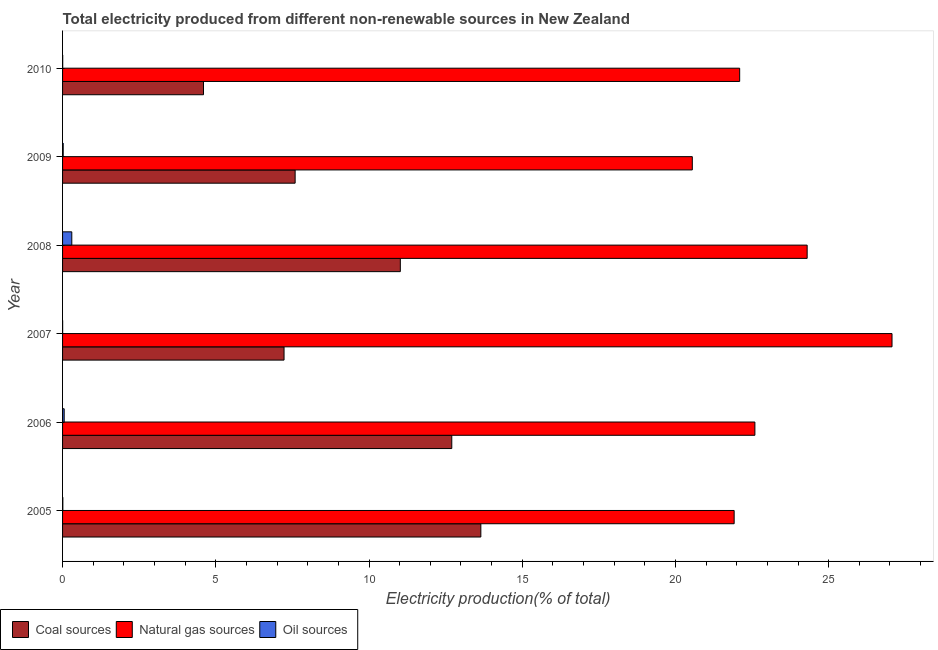How many different coloured bars are there?
Your answer should be very brief. 3. Are the number of bars per tick equal to the number of legend labels?
Provide a succinct answer. Yes. How many bars are there on the 1st tick from the bottom?
Provide a succinct answer. 3. What is the label of the 3rd group of bars from the top?
Offer a terse response. 2008. In how many cases, is the number of bars for a given year not equal to the number of legend labels?
Provide a short and direct response. 0. What is the percentage of electricity produced by natural gas in 2010?
Provide a succinct answer. 22.1. Across all years, what is the maximum percentage of electricity produced by natural gas?
Give a very brief answer. 27.07. Across all years, what is the minimum percentage of electricity produced by natural gas?
Offer a terse response. 20.55. What is the total percentage of electricity produced by oil sources in the graph?
Your answer should be compact. 0.39. What is the difference between the percentage of electricity produced by oil sources in 2006 and that in 2007?
Make the answer very short. 0.05. What is the difference between the percentage of electricity produced by oil sources in 2008 and the percentage of electricity produced by natural gas in 2005?
Keep it short and to the point. -21.62. What is the average percentage of electricity produced by coal per year?
Provide a succinct answer. 9.46. In the year 2009, what is the difference between the percentage of electricity produced by natural gas and percentage of electricity produced by oil sources?
Make the answer very short. 20.53. In how many years, is the percentage of electricity produced by oil sources greater than 13 %?
Your answer should be compact. 0. What is the ratio of the percentage of electricity produced by natural gas in 2007 to that in 2009?
Give a very brief answer. 1.32. Is the percentage of electricity produced by coal in 2009 less than that in 2010?
Give a very brief answer. No. Is the difference between the percentage of electricity produced by oil sources in 2007 and 2009 greater than the difference between the percentage of electricity produced by natural gas in 2007 and 2009?
Provide a short and direct response. No. What is the difference between the highest and the second highest percentage of electricity produced by coal?
Offer a terse response. 0.95. What is the difference between the highest and the lowest percentage of electricity produced by coal?
Your response must be concise. 9.05. In how many years, is the percentage of electricity produced by oil sources greater than the average percentage of electricity produced by oil sources taken over all years?
Provide a short and direct response. 1. What does the 3rd bar from the top in 2006 represents?
Offer a very short reply. Coal sources. What does the 3rd bar from the bottom in 2010 represents?
Give a very brief answer. Oil sources. How many bars are there?
Give a very brief answer. 18. Are the values on the major ticks of X-axis written in scientific E-notation?
Provide a succinct answer. No. Does the graph contain grids?
Ensure brevity in your answer.  No. Where does the legend appear in the graph?
Your answer should be compact. Bottom left. How many legend labels are there?
Provide a short and direct response. 3. What is the title of the graph?
Offer a very short reply. Total electricity produced from different non-renewable sources in New Zealand. What is the label or title of the Y-axis?
Give a very brief answer. Year. What is the Electricity production(% of total) of Coal sources in 2005?
Make the answer very short. 13.65. What is the Electricity production(% of total) of Natural gas sources in 2005?
Offer a terse response. 21.92. What is the Electricity production(% of total) of Oil sources in 2005?
Offer a very short reply. 0.01. What is the Electricity production(% of total) of Coal sources in 2006?
Ensure brevity in your answer.  12.7. What is the Electricity production(% of total) in Natural gas sources in 2006?
Your answer should be very brief. 22.59. What is the Electricity production(% of total) of Oil sources in 2006?
Give a very brief answer. 0.05. What is the Electricity production(% of total) of Coal sources in 2007?
Provide a short and direct response. 7.23. What is the Electricity production(% of total) in Natural gas sources in 2007?
Your answer should be very brief. 27.07. What is the Electricity production(% of total) in Oil sources in 2007?
Provide a succinct answer. 0. What is the Electricity production(% of total) in Coal sources in 2008?
Ensure brevity in your answer.  11.02. What is the Electricity production(% of total) of Natural gas sources in 2008?
Ensure brevity in your answer.  24.3. What is the Electricity production(% of total) of Oil sources in 2008?
Your answer should be compact. 0.3. What is the Electricity production(% of total) in Coal sources in 2009?
Offer a terse response. 7.59. What is the Electricity production(% of total) of Natural gas sources in 2009?
Your answer should be compact. 20.55. What is the Electricity production(% of total) of Oil sources in 2009?
Give a very brief answer. 0.02. What is the Electricity production(% of total) of Coal sources in 2010?
Offer a terse response. 4.6. What is the Electricity production(% of total) in Natural gas sources in 2010?
Provide a succinct answer. 22.1. What is the Electricity production(% of total) of Oil sources in 2010?
Your response must be concise. 0. Across all years, what is the maximum Electricity production(% of total) of Coal sources?
Make the answer very short. 13.65. Across all years, what is the maximum Electricity production(% of total) of Natural gas sources?
Ensure brevity in your answer.  27.07. Across all years, what is the maximum Electricity production(% of total) in Oil sources?
Ensure brevity in your answer.  0.3. Across all years, what is the minimum Electricity production(% of total) in Coal sources?
Provide a succinct answer. 4.6. Across all years, what is the minimum Electricity production(% of total) in Natural gas sources?
Your answer should be very brief. 20.55. Across all years, what is the minimum Electricity production(% of total) in Oil sources?
Give a very brief answer. 0. What is the total Electricity production(% of total) of Coal sources in the graph?
Your answer should be compact. 56.79. What is the total Electricity production(% of total) in Natural gas sources in the graph?
Your response must be concise. 138.52. What is the total Electricity production(% of total) in Oil sources in the graph?
Offer a very short reply. 0.39. What is the difference between the Electricity production(% of total) in Coal sources in 2005 and that in 2006?
Your response must be concise. 0.95. What is the difference between the Electricity production(% of total) of Natural gas sources in 2005 and that in 2006?
Give a very brief answer. -0.68. What is the difference between the Electricity production(% of total) of Oil sources in 2005 and that in 2006?
Your answer should be compact. -0.04. What is the difference between the Electricity production(% of total) of Coal sources in 2005 and that in 2007?
Give a very brief answer. 6.42. What is the difference between the Electricity production(% of total) of Natural gas sources in 2005 and that in 2007?
Your response must be concise. -5.15. What is the difference between the Electricity production(% of total) of Oil sources in 2005 and that in 2007?
Provide a succinct answer. 0.01. What is the difference between the Electricity production(% of total) of Coal sources in 2005 and that in 2008?
Your response must be concise. 2.63. What is the difference between the Electricity production(% of total) in Natural gas sources in 2005 and that in 2008?
Provide a succinct answer. -2.38. What is the difference between the Electricity production(% of total) in Oil sources in 2005 and that in 2008?
Offer a terse response. -0.29. What is the difference between the Electricity production(% of total) in Coal sources in 2005 and that in 2009?
Provide a short and direct response. 6.06. What is the difference between the Electricity production(% of total) of Natural gas sources in 2005 and that in 2009?
Ensure brevity in your answer.  1.37. What is the difference between the Electricity production(% of total) of Oil sources in 2005 and that in 2009?
Make the answer very short. -0.01. What is the difference between the Electricity production(% of total) of Coal sources in 2005 and that in 2010?
Ensure brevity in your answer.  9.05. What is the difference between the Electricity production(% of total) of Natural gas sources in 2005 and that in 2010?
Your answer should be compact. -0.18. What is the difference between the Electricity production(% of total) in Oil sources in 2005 and that in 2010?
Your answer should be compact. 0. What is the difference between the Electricity production(% of total) of Coal sources in 2006 and that in 2007?
Offer a terse response. 5.47. What is the difference between the Electricity production(% of total) of Natural gas sources in 2006 and that in 2007?
Your answer should be very brief. -4.47. What is the difference between the Electricity production(% of total) in Oil sources in 2006 and that in 2007?
Make the answer very short. 0.05. What is the difference between the Electricity production(% of total) in Coal sources in 2006 and that in 2008?
Your answer should be compact. 1.68. What is the difference between the Electricity production(% of total) of Natural gas sources in 2006 and that in 2008?
Offer a very short reply. -1.71. What is the difference between the Electricity production(% of total) in Oil sources in 2006 and that in 2008?
Provide a short and direct response. -0.25. What is the difference between the Electricity production(% of total) of Coal sources in 2006 and that in 2009?
Ensure brevity in your answer.  5.11. What is the difference between the Electricity production(% of total) of Natural gas sources in 2006 and that in 2009?
Provide a short and direct response. 2.04. What is the difference between the Electricity production(% of total) of Oil sources in 2006 and that in 2009?
Ensure brevity in your answer.  0.03. What is the difference between the Electricity production(% of total) of Coal sources in 2006 and that in 2010?
Make the answer very short. 8.1. What is the difference between the Electricity production(% of total) in Natural gas sources in 2006 and that in 2010?
Ensure brevity in your answer.  0.5. What is the difference between the Electricity production(% of total) of Oil sources in 2006 and that in 2010?
Your answer should be very brief. 0.05. What is the difference between the Electricity production(% of total) of Coal sources in 2007 and that in 2008?
Provide a succinct answer. -3.79. What is the difference between the Electricity production(% of total) in Natural gas sources in 2007 and that in 2008?
Ensure brevity in your answer.  2.77. What is the difference between the Electricity production(% of total) of Oil sources in 2007 and that in 2008?
Provide a succinct answer. -0.3. What is the difference between the Electricity production(% of total) of Coal sources in 2007 and that in 2009?
Provide a short and direct response. -0.36. What is the difference between the Electricity production(% of total) in Natural gas sources in 2007 and that in 2009?
Your answer should be compact. 6.52. What is the difference between the Electricity production(% of total) of Oil sources in 2007 and that in 2009?
Offer a terse response. -0.02. What is the difference between the Electricity production(% of total) in Coal sources in 2007 and that in 2010?
Offer a terse response. 2.63. What is the difference between the Electricity production(% of total) of Natural gas sources in 2007 and that in 2010?
Offer a very short reply. 4.97. What is the difference between the Electricity production(% of total) of Oil sources in 2007 and that in 2010?
Offer a terse response. -0. What is the difference between the Electricity production(% of total) in Coal sources in 2008 and that in 2009?
Ensure brevity in your answer.  3.43. What is the difference between the Electricity production(% of total) in Natural gas sources in 2008 and that in 2009?
Your answer should be compact. 3.75. What is the difference between the Electricity production(% of total) of Oil sources in 2008 and that in 2009?
Your answer should be compact. 0.28. What is the difference between the Electricity production(% of total) of Coal sources in 2008 and that in 2010?
Offer a very short reply. 6.42. What is the difference between the Electricity production(% of total) of Natural gas sources in 2008 and that in 2010?
Make the answer very short. 2.2. What is the difference between the Electricity production(% of total) in Oil sources in 2008 and that in 2010?
Provide a succinct answer. 0.3. What is the difference between the Electricity production(% of total) of Coal sources in 2009 and that in 2010?
Offer a very short reply. 2.99. What is the difference between the Electricity production(% of total) of Natural gas sources in 2009 and that in 2010?
Offer a very short reply. -1.55. What is the difference between the Electricity production(% of total) of Oil sources in 2009 and that in 2010?
Provide a succinct answer. 0.02. What is the difference between the Electricity production(% of total) in Coal sources in 2005 and the Electricity production(% of total) in Natural gas sources in 2006?
Provide a succinct answer. -8.94. What is the difference between the Electricity production(% of total) in Coal sources in 2005 and the Electricity production(% of total) in Oil sources in 2006?
Your answer should be very brief. 13.6. What is the difference between the Electricity production(% of total) in Natural gas sources in 2005 and the Electricity production(% of total) in Oil sources in 2006?
Offer a terse response. 21.86. What is the difference between the Electricity production(% of total) of Coal sources in 2005 and the Electricity production(% of total) of Natural gas sources in 2007?
Your answer should be very brief. -13.42. What is the difference between the Electricity production(% of total) of Coal sources in 2005 and the Electricity production(% of total) of Oil sources in 2007?
Your response must be concise. 13.65. What is the difference between the Electricity production(% of total) in Natural gas sources in 2005 and the Electricity production(% of total) in Oil sources in 2007?
Provide a short and direct response. 21.91. What is the difference between the Electricity production(% of total) of Coal sources in 2005 and the Electricity production(% of total) of Natural gas sources in 2008?
Provide a succinct answer. -10.65. What is the difference between the Electricity production(% of total) in Coal sources in 2005 and the Electricity production(% of total) in Oil sources in 2008?
Provide a succinct answer. 13.35. What is the difference between the Electricity production(% of total) of Natural gas sources in 2005 and the Electricity production(% of total) of Oil sources in 2008?
Your answer should be compact. 21.62. What is the difference between the Electricity production(% of total) in Coal sources in 2005 and the Electricity production(% of total) in Natural gas sources in 2009?
Your response must be concise. -6.9. What is the difference between the Electricity production(% of total) of Coal sources in 2005 and the Electricity production(% of total) of Oil sources in 2009?
Your answer should be very brief. 13.63. What is the difference between the Electricity production(% of total) in Natural gas sources in 2005 and the Electricity production(% of total) in Oil sources in 2009?
Offer a terse response. 21.9. What is the difference between the Electricity production(% of total) of Coal sources in 2005 and the Electricity production(% of total) of Natural gas sources in 2010?
Make the answer very short. -8.45. What is the difference between the Electricity production(% of total) of Coal sources in 2005 and the Electricity production(% of total) of Oil sources in 2010?
Provide a short and direct response. 13.65. What is the difference between the Electricity production(% of total) in Natural gas sources in 2005 and the Electricity production(% of total) in Oil sources in 2010?
Offer a terse response. 21.91. What is the difference between the Electricity production(% of total) in Coal sources in 2006 and the Electricity production(% of total) in Natural gas sources in 2007?
Make the answer very short. -14.37. What is the difference between the Electricity production(% of total) in Coal sources in 2006 and the Electricity production(% of total) in Oil sources in 2007?
Give a very brief answer. 12.7. What is the difference between the Electricity production(% of total) in Natural gas sources in 2006 and the Electricity production(% of total) in Oil sources in 2007?
Your response must be concise. 22.59. What is the difference between the Electricity production(% of total) in Coal sources in 2006 and the Electricity production(% of total) in Natural gas sources in 2008?
Offer a terse response. -11.6. What is the difference between the Electricity production(% of total) of Coal sources in 2006 and the Electricity production(% of total) of Oil sources in 2008?
Your answer should be very brief. 12.4. What is the difference between the Electricity production(% of total) of Natural gas sources in 2006 and the Electricity production(% of total) of Oil sources in 2008?
Keep it short and to the point. 22.29. What is the difference between the Electricity production(% of total) in Coal sources in 2006 and the Electricity production(% of total) in Natural gas sources in 2009?
Make the answer very short. -7.85. What is the difference between the Electricity production(% of total) of Coal sources in 2006 and the Electricity production(% of total) of Oil sources in 2009?
Keep it short and to the point. 12.68. What is the difference between the Electricity production(% of total) in Natural gas sources in 2006 and the Electricity production(% of total) in Oil sources in 2009?
Make the answer very short. 22.57. What is the difference between the Electricity production(% of total) in Coal sources in 2006 and the Electricity production(% of total) in Natural gas sources in 2010?
Provide a succinct answer. -9.4. What is the difference between the Electricity production(% of total) of Coal sources in 2006 and the Electricity production(% of total) of Oil sources in 2010?
Your answer should be very brief. 12.7. What is the difference between the Electricity production(% of total) of Natural gas sources in 2006 and the Electricity production(% of total) of Oil sources in 2010?
Give a very brief answer. 22.59. What is the difference between the Electricity production(% of total) in Coal sources in 2007 and the Electricity production(% of total) in Natural gas sources in 2008?
Keep it short and to the point. -17.07. What is the difference between the Electricity production(% of total) of Coal sources in 2007 and the Electricity production(% of total) of Oil sources in 2008?
Your response must be concise. 6.93. What is the difference between the Electricity production(% of total) in Natural gas sources in 2007 and the Electricity production(% of total) in Oil sources in 2008?
Keep it short and to the point. 26.77. What is the difference between the Electricity production(% of total) of Coal sources in 2007 and the Electricity production(% of total) of Natural gas sources in 2009?
Your response must be concise. -13.32. What is the difference between the Electricity production(% of total) in Coal sources in 2007 and the Electricity production(% of total) in Oil sources in 2009?
Make the answer very short. 7.21. What is the difference between the Electricity production(% of total) of Natural gas sources in 2007 and the Electricity production(% of total) of Oil sources in 2009?
Give a very brief answer. 27.05. What is the difference between the Electricity production(% of total) in Coal sources in 2007 and the Electricity production(% of total) in Natural gas sources in 2010?
Give a very brief answer. -14.87. What is the difference between the Electricity production(% of total) of Coal sources in 2007 and the Electricity production(% of total) of Oil sources in 2010?
Provide a succinct answer. 7.22. What is the difference between the Electricity production(% of total) of Natural gas sources in 2007 and the Electricity production(% of total) of Oil sources in 2010?
Your answer should be compact. 27.06. What is the difference between the Electricity production(% of total) in Coal sources in 2008 and the Electricity production(% of total) in Natural gas sources in 2009?
Provide a short and direct response. -9.53. What is the difference between the Electricity production(% of total) in Coal sources in 2008 and the Electricity production(% of total) in Oil sources in 2009?
Keep it short and to the point. 11. What is the difference between the Electricity production(% of total) in Natural gas sources in 2008 and the Electricity production(% of total) in Oil sources in 2009?
Provide a short and direct response. 24.28. What is the difference between the Electricity production(% of total) in Coal sources in 2008 and the Electricity production(% of total) in Natural gas sources in 2010?
Ensure brevity in your answer.  -11.07. What is the difference between the Electricity production(% of total) in Coal sources in 2008 and the Electricity production(% of total) in Oil sources in 2010?
Give a very brief answer. 11.02. What is the difference between the Electricity production(% of total) in Natural gas sources in 2008 and the Electricity production(% of total) in Oil sources in 2010?
Give a very brief answer. 24.29. What is the difference between the Electricity production(% of total) of Coal sources in 2009 and the Electricity production(% of total) of Natural gas sources in 2010?
Provide a succinct answer. -14.51. What is the difference between the Electricity production(% of total) of Coal sources in 2009 and the Electricity production(% of total) of Oil sources in 2010?
Your answer should be very brief. 7.59. What is the difference between the Electricity production(% of total) in Natural gas sources in 2009 and the Electricity production(% of total) in Oil sources in 2010?
Make the answer very short. 20.55. What is the average Electricity production(% of total) in Coal sources per year?
Keep it short and to the point. 9.46. What is the average Electricity production(% of total) in Natural gas sources per year?
Keep it short and to the point. 23.09. What is the average Electricity production(% of total) of Oil sources per year?
Your answer should be compact. 0.07. In the year 2005, what is the difference between the Electricity production(% of total) in Coal sources and Electricity production(% of total) in Natural gas sources?
Provide a short and direct response. -8.27. In the year 2005, what is the difference between the Electricity production(% of total) of Coal sources and Electricity production(% of total) of Oil sources?
Give a very brief answer. 13.64. In the year 2005, what is the difference between the Electricity production(% of total) of Natural gas sources and Electricity production(% of total) of Oil sources?
Provide a succinct answer. 21.91. In the year 2006, what is the difference between the Electricity production(% of total) in Coal sources and Electricity production(% of total) in Natural gas sources?
Offer a very short reply. -9.89. In the year 2006, what is the difference between the Electricity production(% of total) in Coal sources and Electricity production(% of total) in Oil sources?
Provide a short and direct response. 12.65. In the year 2006, what is the difference between the Electricity production(% of total) in Natural gas sources and Electricity production(% of total) in Oil sources?
Ensure brevity in your answer.  22.54. In the year 2007, what is the difference between the Electricity production(% of total) of Coal sources and Electricity production(% of total) of Natural gas sources?
Make the answer very short. -19.84. In the year 2007, what is the difference between the Electricity production(% of total) of Coal sources and Electricity production(% of total) of Oil sources?
Provide a succinct answer. 7.23. In the year 2007, what is the difference between the Electricity production(% of total) of Natural gas sources and Electricity production(% of total) of Oil sources?
Give a very brief answer. 27.07. In the year 2008, what is the difference between the Electricity production(% of total) in Coal sources and Electricity production(% of total) in Natural gas sources?
Your answer should be very brief. -13.28. In the year 2008, what is the difference between the Electricity production(% of total) in Coal sources and Electricity production(% of total) in Oil sources?
Your response must be concise. 10.72. In the year 2008, what is the difference between the Electricity production(% of total) of Natural gas sources and Electricity production(% of total) of Oil sources?
Your answer should be very brief. 24. In the year 2009, what is the difference between the Electricity production(% of total) in Coal sources and Electricity production(% of total) in Natural gas sources?
Provide a short and direct response. -12.96. In the year 2009, what is the difference between the Electricity production(% of total) of Coal sources and Electricity production(% of total) of Oil sources?
Ensure brevity in your answer.  7.57. In the year 2009, what is the difference between the Electricity production(% of total) of Natural gas sources and Electricity production(% of total) of Oil sources?
Your response must be concise. 20.53. In the year 2010, what is the difference between the Electricity production(% of total) of Coal sources and Electricity production(% of total) of Natural gas sources?
Provide a succinct answer. -17.5. In the year 2010, what is the difference between the Electricity production(% of total) of Coal sources and Electricity production(% of total) of Oil sources?
Make the answer very short. 4.59. In the year 2010, what is the difference between the Electricity production(% of total) in Natural gas sources and Electricity production(% of total) in Oil sources?
Your answer should be very brief. 22.09. What is the ratio of the Electricity production(% of total) in Coal sources in 2005 to that in 2006?
Offer a terse response. 1.07. What is the ratio of the Electricity production(% of total) in Oil sources in 2005 to that in 2006?
Your answer should be very brief. 0.18. What is the ratio of the Electricity production(% of total) of Coal sources in 2005 to that in 2007?
Offer a very short reply. 1.89. What is the ratio of the Electricity production(% of total) in Natural gas sources in 2005 to that in 2007?
Your response must be concise. 0.81. What is the ratio of the Electricity production(% of total) of Oil sources in 2005 to that in 2007?
Give a very brief answer. 4.07. What is the ratio of the Electricity production(% of total) in Coal sources in 2005 to that in 2008?
Give a very brief answer. 1.24. What is the ratio of the Electricity production(% of total) of Natural gas sources in 2005 to that in 2008?
Provide a short and direct response. 0.9. What is the ratio of the Electricity production(% of total) in Oil sources in 2005 to that in 2008?
Make the answer very short. 0.03. What is the ratio of the Electricity production(% of total) of Coal sources in 2005 to that in 2009?
Your answer should be compact. 1.8. What is the ratio of the Electricity production(% of total) in Natural gas sources in 2005 to that in 2009?
Your answer should be compact. 1.07. What is the ratio of the Electricity production(% of total) of Oil sources in 2005 to that in 2009?
Your answer should be compact. 0.45. What is the ratio of the Electricity production(% of total) of Coal sources in 2005 to that in 2010?
Offer a very short reply. 2.97. What is the ratio of the Electricity production(% of total) of Natural gas sources in 2005 to that in 2010?
Provide a short and direct response. 0.99. What is the ratio of the Electricity production(% of total) in Oil sources in 2005 to that in 2010?
Offer a very short reply. 2.09. What is the ratio of the Electricity production(% of total) of Coal sources in 2006 to that in 2007?
Provide a short and direct response. 1.76. What is the ratio of the Electricity production(% of total) in Natural gas sources in 2006 to that in 2007?
Offer a very short reply. 0.83. What is the ratio of the Electricity production(% of total) in Oil sources in 2006 to that in 2007?
Offer a very short reply. 23.08. What is the ratio of the Electricity production(% of total) of Coal sources in 2006 to that in 2008?
Give a very brief answer. 1.15. What is the ratio of the Electricity production(% of total) in Natural gas sources in 2006 to that in 2008?
Your answer should be compact. 0.93. What is the ratio of the Electricity production(% of total) in Oil sources in 2006 to that in 2008?
Ensure brevity in your answer.  0.18. What is the ratio of the Electricity production(% of total) in Coal sources in 2006 to that in 2009?
Ensure brevity in your answer.  1.67. What is the ratio of the Electricity production(% of total) of Natural gas sources in 2006 to that in 2009?
Make the answer very short. 1.1. What is the ratio of the Electricity production(% of total) in Oil sources in 2006 to that in 2009?
Your response must be concise. 2.55. What is the ratio of the Electricity production(% of total) of Coal sources in 2006 to that in 2010?
Make the answer very short. 2.76. What is the ratio of the Electricity production(% of total) of Natural gas sources in 2006 to that in 2010?
Keep it short and to the point. 1.02. What is the ratio of the Electricity production(% of total) in Oil sources in 2006 to that in 2010?
Ensure brevity in your answer.  11.84. What is the ratio of the Electricity production(% of total) of Coal sources in 2007 to that in 2008?
Provide a short and direct response. 0.66. What is the ratio of the Electricity production(% of total) in Natural gas sources in 2007 to that in 2008?
Make the answer very short. 1.11. What is the ratio of the Electricity production(% of total) of Oil sources in 2007 to that in 2008?
Offer a very short reply. 0.01. What is the ratio of the Electricity production(% of total) of Coal sources in 2007 to that in 2009?
Your response must be concise. 0.95. What is the ratio of the Electricity production(% of total) in Natural gas sources in 2007 to that in 2009?
Your response must be concise. 1.32. What is the ratio of the Electricity production(% of total) of Oil sources in 2007 to that in 2009?
Make the answer very short. 0.11. What is the ratio of the Electricity production(% of total) of Coal sources in 2007 to that in 2010?
Your response must be concise. 1.57. What is the ratio of the Electricity production(% of total) of Natural gas sources in 2007 to that in 2010?
Your answer should be compact. 1.23. What is the ratio of the Electricity production(% of total) in Oil sources in 2007 to that in 2010?
Give a very brief answer. 0.51. What is the ratio of the Electricity production(% of total) of Coal sources in 2008 to that in 2009?
Keep it short and to the point. 1.45. What is the ratio of the Electricity production(% of total) of Natural gas sources in 2008 to that in 2009?
Keep it short and to the point. 1.18. What is the ratio of the Electricity production(% of total) in Oil sources in 2008 to that in 2009?
Give a very brief answer. 14.54. What is the ratio of the Electricity production(% of total) of Coal sources in 2008 to that in 2010?
Give a very brief answer. 2.4. What is the ratio of the Electricity production(% of total) in Natural gas sources in 2008 to that in 2010?
Make the answer very short. 1.1. What is the ratio of the Electricity production(% of total) in Oil sources in 2008 to that in 2010?
Ensure brevity in your answer.  67.56. What is the ratio of the Electricity production(% of total) of Coal sources in 2009 to that in 2010?
Your answer should be very brief. 1.65. What is the ratio of the Electricity production(% of total) in Natural gas sources in 2009 to that in 2010?
Give a very brief answer. 0.93. What is the ratio of the Electricity production(% of total) in Oil sources in 2009 to that in 2010?
Your answer should be very brief. 4.65. What is the difference between the highest and the second highest Electricity production(% of total) in Coal sources?
Give a very brief answer. 0.95. What is the difference between the highest and the second highest Electricity production(% of total) of Natural gas sources?
Provide a short and direct response. 2.77. What is the difference between the highest and the second highest Electricity production(% of total) of Oil sources?
Provide a short and direct response. 0.25. What is the difference between the highest and the lowest Electricity production(% of total) of Coal sources?
Offer a very short reply. 9.05. What is the difference between the highest and the lowest Electricity production(% of total) of Natural gas sources?
Make the answer very short. 6.52. What is the difference between the highest and the lowest Electricity production(% of total) of Oil sources?
Keep it short and to the point. 0.3. 